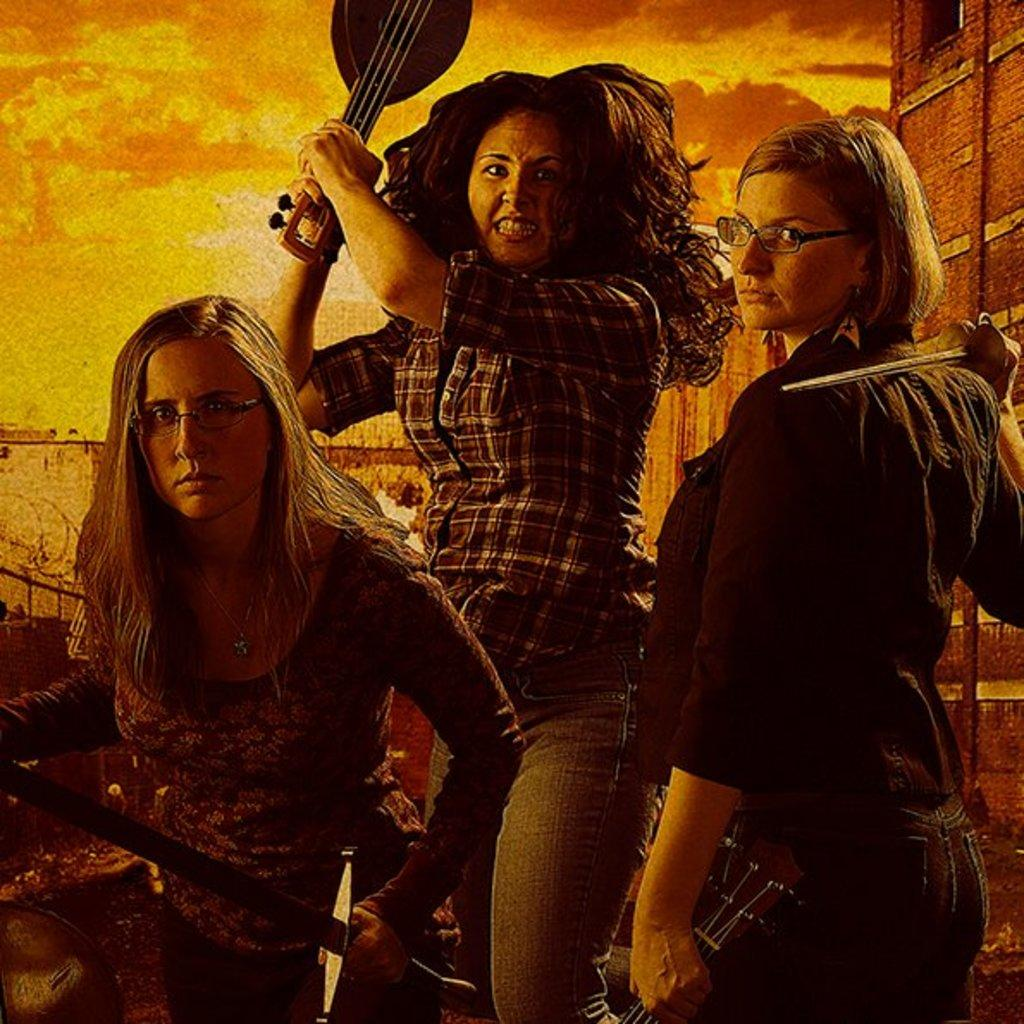How many people are in the image? There are three persons in the image. What are the persons doing in the image? The persons are standing and holding musical instruments. Can you describe any specific features of the persons? Two of the persons are wearing spectacles. What can be seen in the background of the image? There is a wall visible in the background of the image. What type of food is being served in the park in the image? There is no park or food present in the image; it features three persons standing and holding musical instruments. 